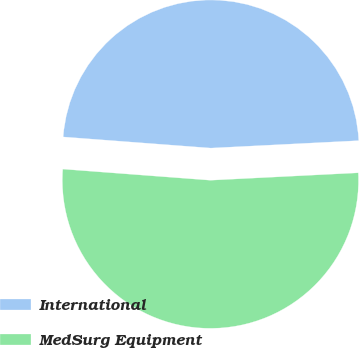<chart> <loc_0><loc_0><loc_500><loc_500><pie_chart><fcel>International<fcel>MedSurg Equipment<nl><fcel>48.0%<fcel>52.0%<nl></chart> 